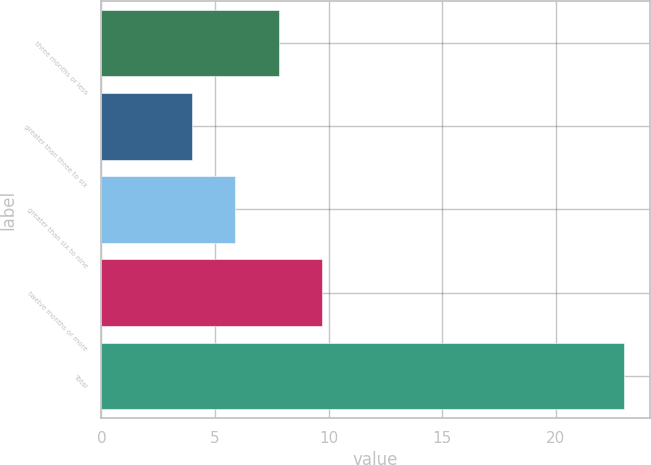Convert chart. <chart><loc_0><loc_0><loc_500><loc_500><bar_chart><fcel>three months or less<fcel>greater than three to six<fcel>greater than six to nine<fcel>twelve months or more<fcel>Total<nl><fcel>7.8<fcel>4<fcel>5.9<fcel>9.7<fcel>23<nl></chart> 